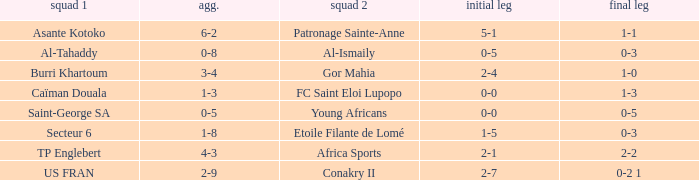Which team lost 0-3 and 0-5? Al-Tahaddy. 